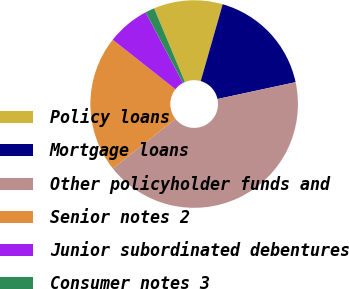Convert chart. <chart><loc_0><loc_0><loc_500><loc_500><pie_chart><fcel>Policy loans<fcel>Mortgage loans<fcel>Other policyholder funds and<fcel>Senior notes 2<fcel>Junior subordinated debentures<fcel>Consumer notes 3<nl><fcel>10.74%<fcel>17.19%<fcel>42.71%<fcel>21.31%<fcel>6.61%<fcel>1.44%<nl></chart> 